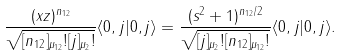<formula> <loc_0><loc_0><loc_500><loc_500>\frac { ( x z ) ^ { n _ { 1 2 } } } { \sqrt { [ n _ { 1 2 } ] _ { \mu _ { 1 2 } } ! [ j ] _ { \mu _ { 2 } } ! } } \langle 0 , j | 0 , j \rangle = \frac { ( s ^ { 2 } + 1 ) ^ { n _ { 1 2 } / 2 } } { \sqrt { [ j ] _ { \mu _ { 2 } } ! [ n _ { 1 2 } ] _ { \mu _ { 1 2 } } ! } } \langle 0 , j | 0 , j \rangle .</formula> 